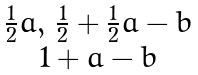<formula> <loc_0><loc_0><loc_500><loc_500>\begin{matrix} \frac { 1 } { 2 } a , \, \frac { 1 } { 2 } + \frac { 1 } { 2 } a - b \\ 1 + a - b \end{matrix}</formula> 